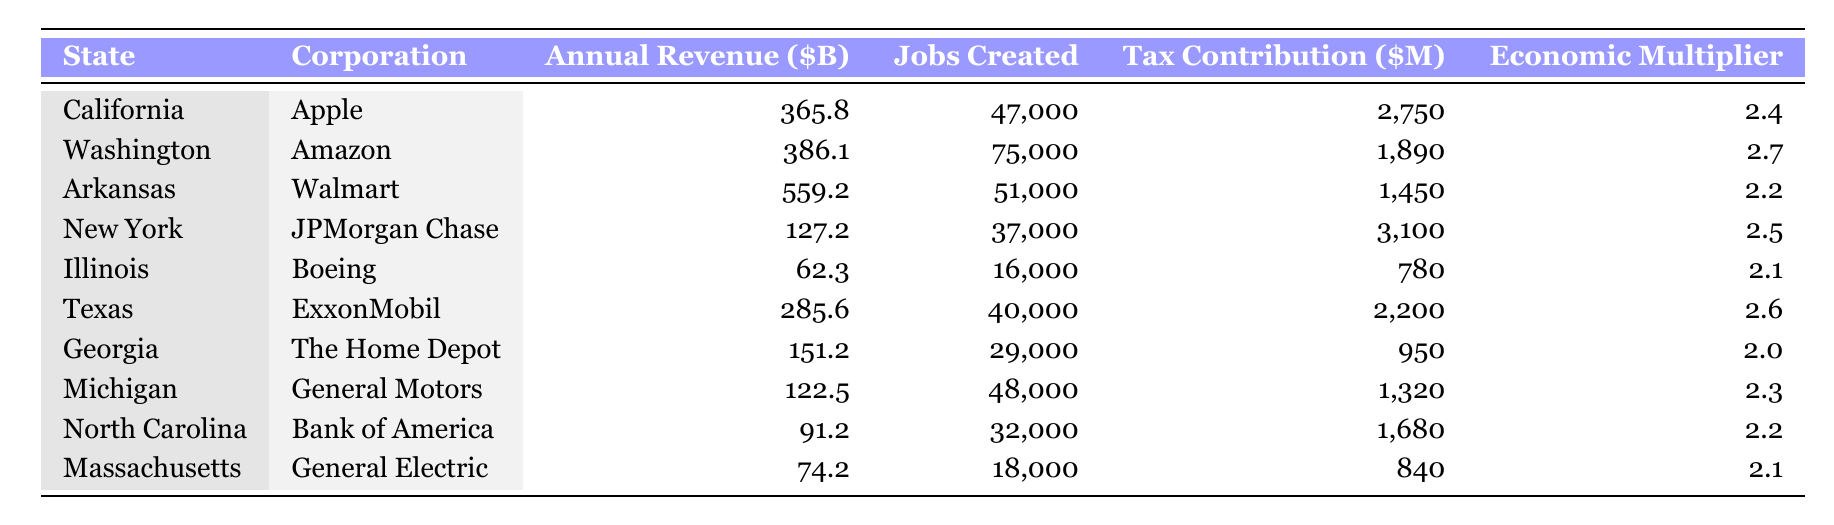What is the annual revenue of Amazon? The table shows that Amazon is associated with the state of Washington, and its annual revenue is listed as 386.1 billion dollars.
Answer: 386.1 billion dollars Which corporation created the most jobs? By examining the "Jobs Created" column, we see that Amazon leads with 75,000 jobs created, while Walmart follows with 51,000 jobs.
Answer: Amazon What is the total annual revenue of the corporations based in the top three states by revenue? The top three states by annual revenue are Arkansas (559.2), Washington (386.1), and California (365.8). Summing these values gives 559.2 + 386.1 + 365.8 = 1311.1 billion dollars.
Answer: 1311.1 billion dollars Is the economic multiplier for The Home Depot greater than 2? The economic multiplier for The Home Depot is listed as 2.0, which is not greater than 2.
Answer: No Which corporation has the highest tax contribution in New York? The corporation listed for New York is JPMorgan Chase, which has a tax contribution of 3100 million dollars, the highest in the state.
Answer: JPMorgan Chase What is the average number of jobs created by the corporations listed in the table? To find the average, we first sum the jobs created: 47000 + 75000 + 51000 + 37000 + 16000 + 40000 + 29000 + 48000 + 32000 + 18000 = 334000. There are 10 corporations, so the average number of jobs created is 334000 / 10 = 33400.
Answer: 33400 What is the tax contribution of ExxonMobil in Texas? The table indicates ExxonMobil's tax contribution in Texas is listed as 2200 million dollars.
Answer: 2200 million dollars Is the annual revenue of General Motors greater than that of Bank of America? General Motors has an annual revenue of 122.5 billion dollars, while Bank of America has 91.2 billion dollars, which means General Motors has a greater revenue.
Answer: Yes Which state has the lowest tax contribution among the listed corporations? Looking at the "Tax Contribution" column, we find that Boeing in Illinois has the lowest tax contribution at 780 million dollars.
Answer: Illinois 